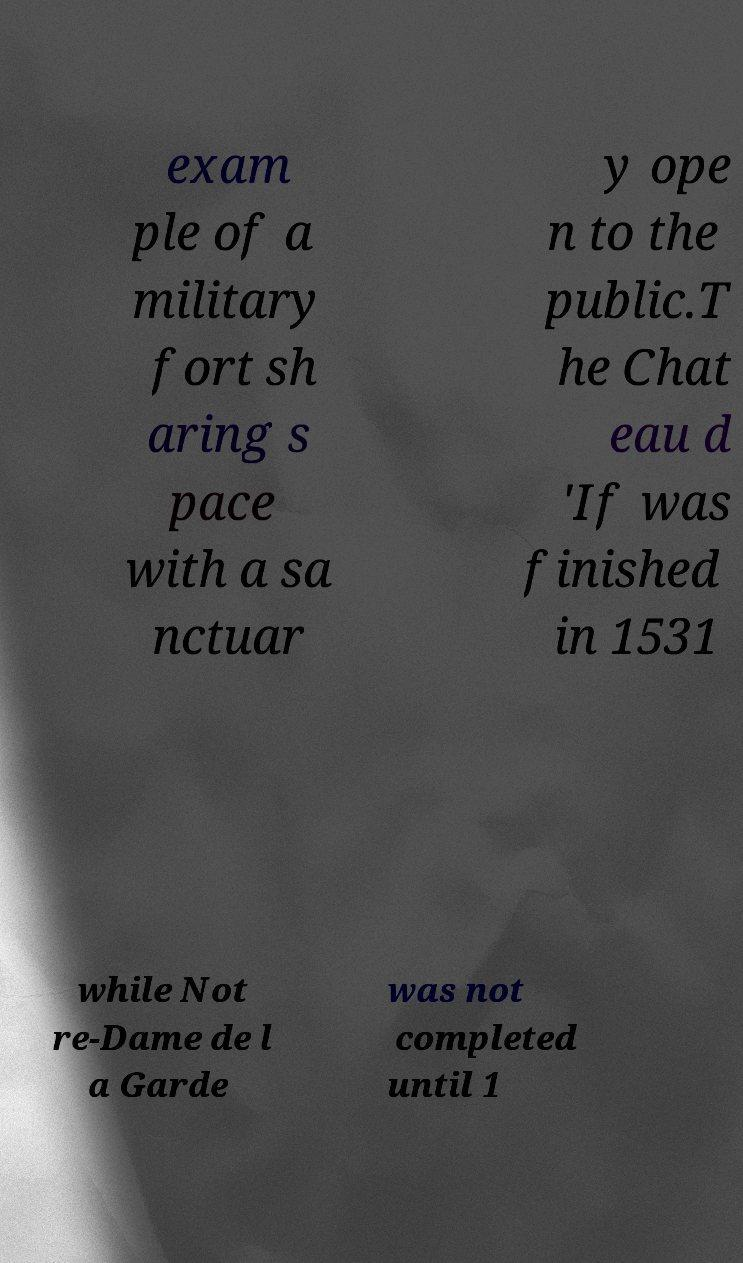Could you assist in decoding the text presented in this image and type it out clearly? exam ple of a military fort sh aring s pace with a sa nctuar y ope n to the public.T he Chat eau d 'If was finished in 1531 while Not re-Dame de l a Garde was not completed until 1 